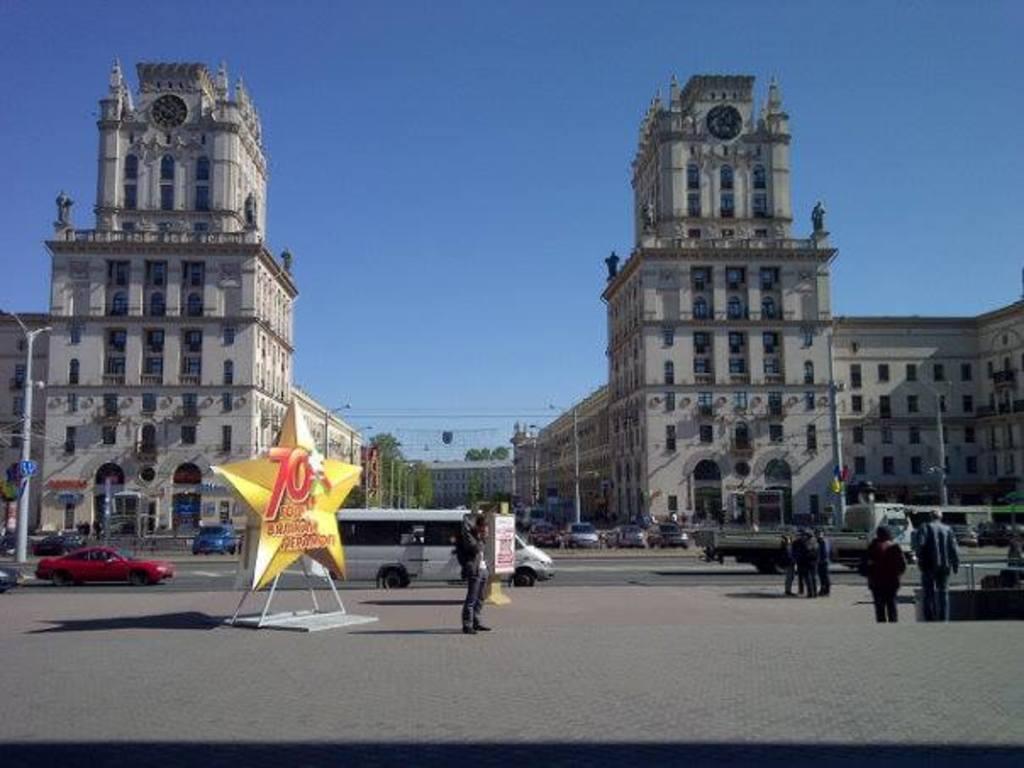Could you give a brief overview of what you see in this image? In this picture I can see buildings, trees and few pole lights and I can see few cars parked and few cars and vehicles moving on the road and few people standing and few are walking and I can see a board with some text and a blue cloudy sky. 